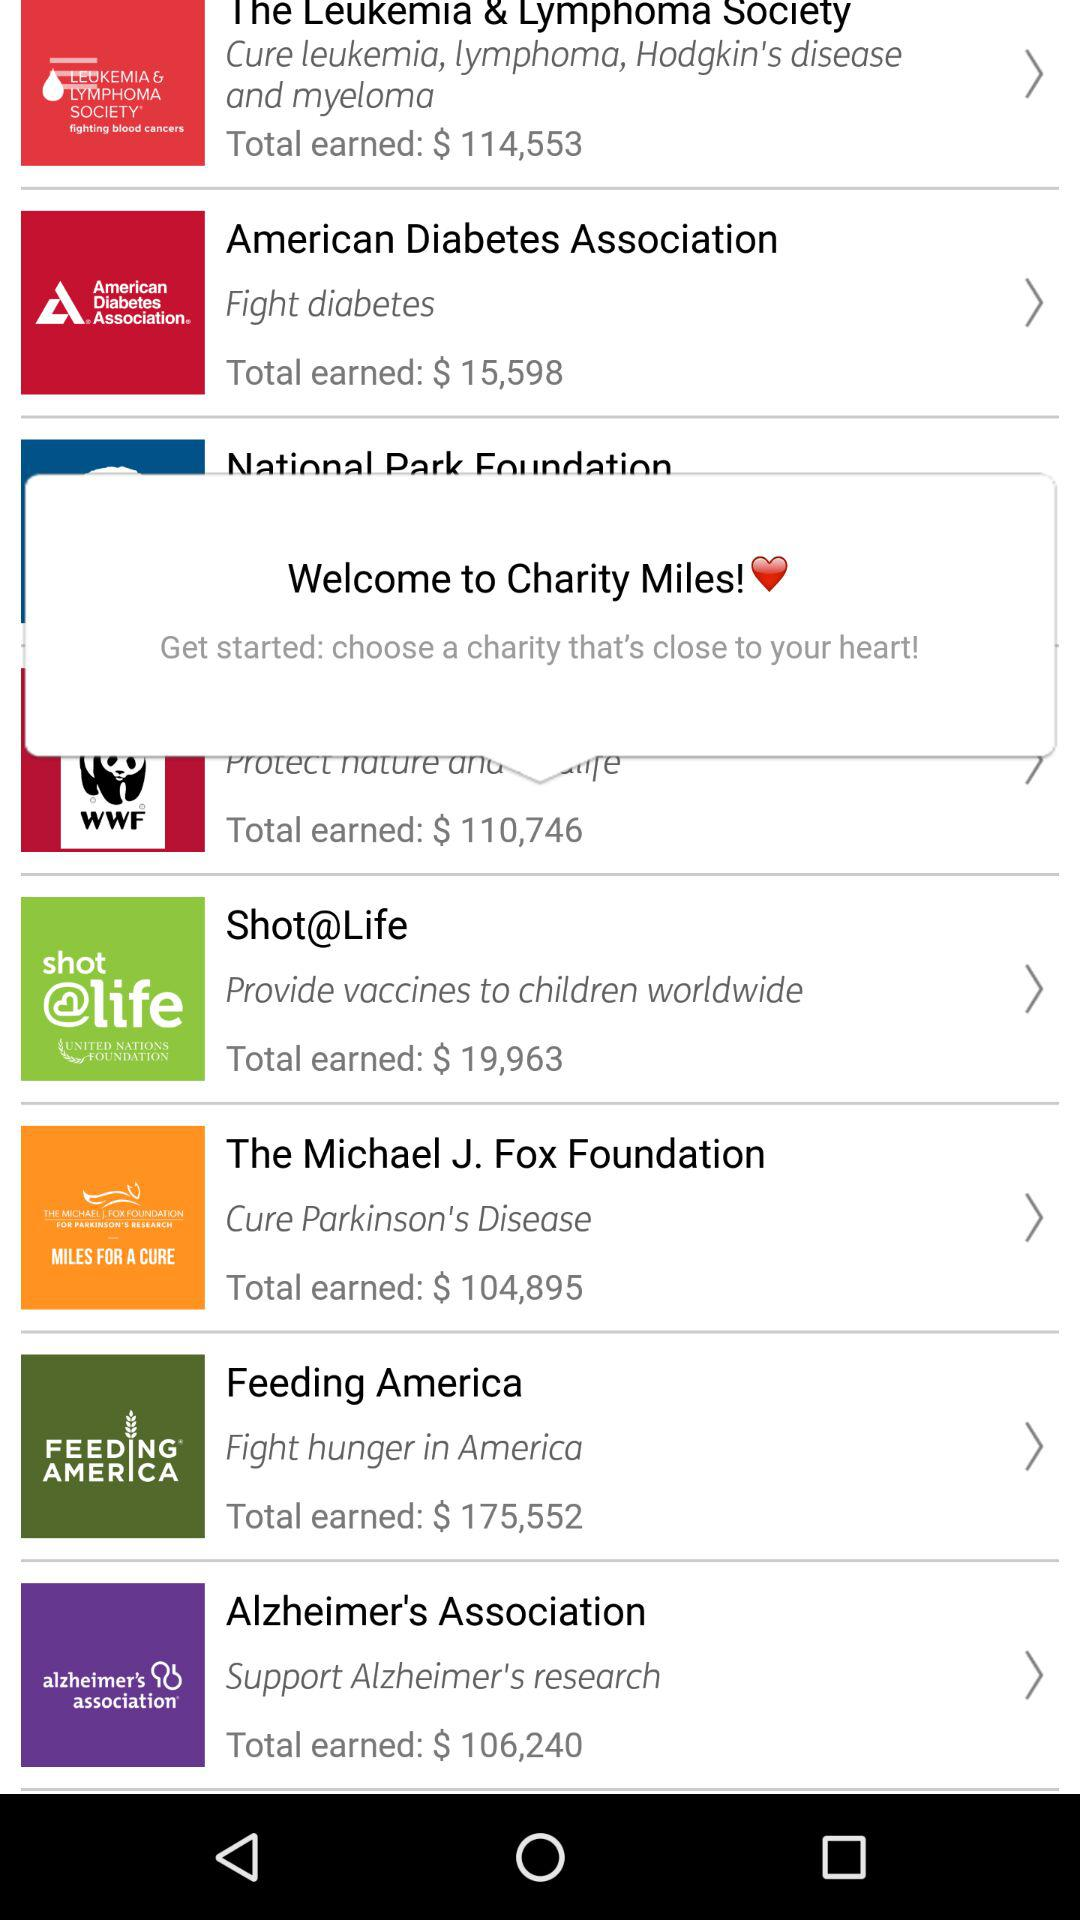What is the total amount earned in $ by "Shot@Life"? The total amount earned by "Shot@Life" is $19,963. 